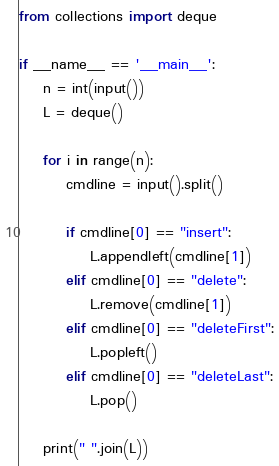<code> <loc_0><loc_0><loc_500><loc_500><_Python_>from collections import deque

if __name__ == '__main__':
	n = int(input())
	L = deque()

	for i in range(n):
		cmdline = input().split()

		if cmdline[0] == "insert":
			L.appendleft(cmdline[1])
		elif cmdline[0] == "delete":
			L.remove(cmdline[1])
		elif cmdline[0] == "deleteFirst":
			L.popleft()
		elif cmdline[0] == "deleteLast":
			L.pop()

	print(" ".join(L))</code> 